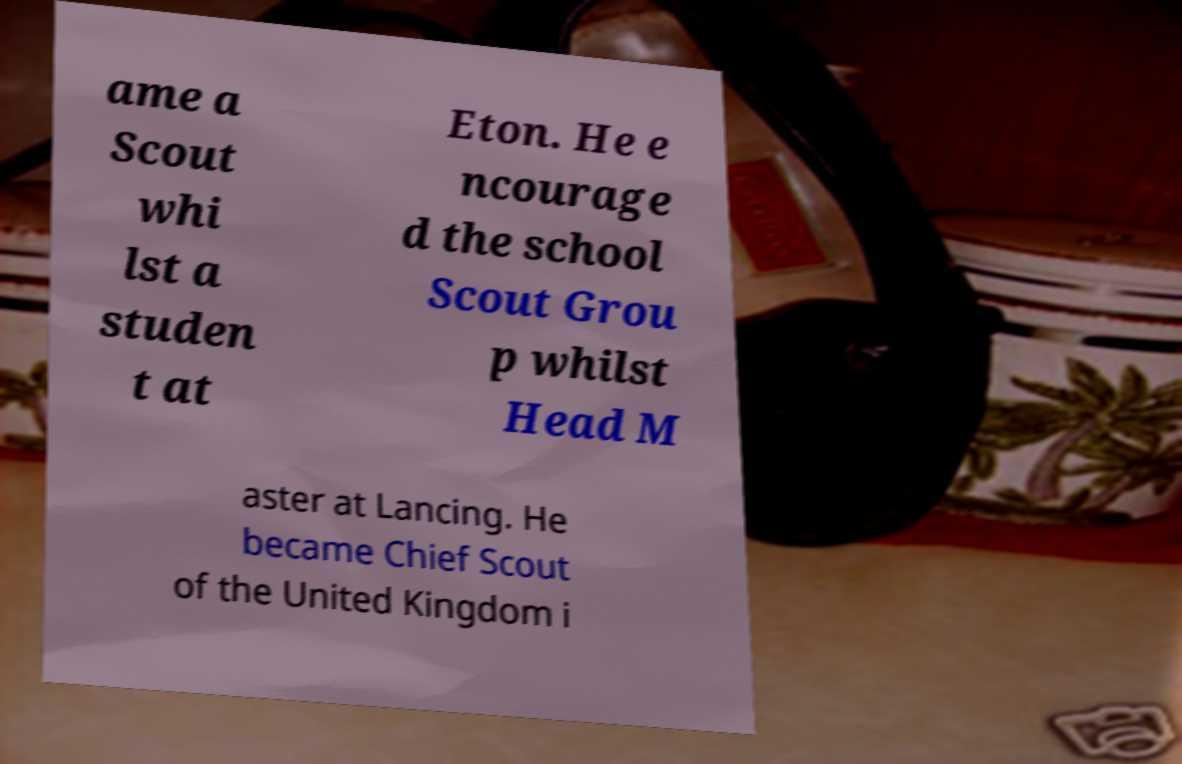Can you accurately transcribe the text from the provided image for me? ame a Scout whi lst a studen t at Eton. He e ncourage d the school Scout Grou p whilst Head M aster at Lancing. He became Chief Scout of the United Kingdom i 